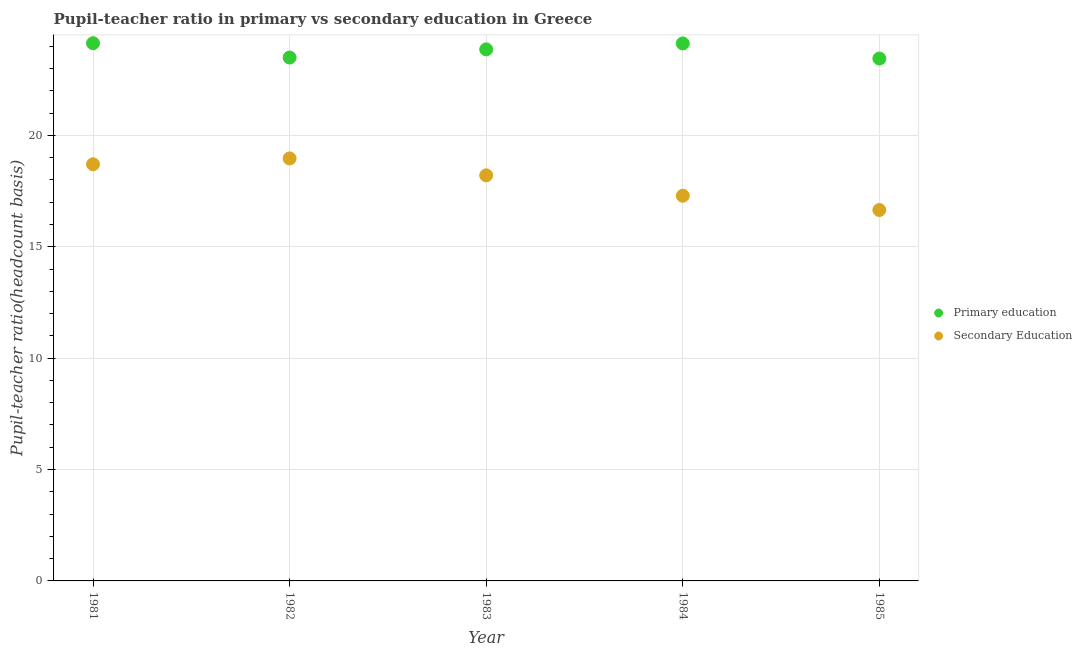Is the number of dotlines equal to the number of legend labels?
Keep it short and to the point. Yes. What is the pupil-teacher ratio in primary education in 1985?
Provide a succinct answer. 23.45. Across all years, what is the maximum pupil teacher ratio on secondary education?
Ensure brevity in your answer.  18.97. Across all years, what is the minimum pupil-teacher ratio in primary education?
Provide a short and direct response. 23.45. What is the total pupil teacher ratio on secondary education in the graph?
Ensure brevity in your answer.  89.81. What is the difference between the pupil-teacher ratio in primary education in 1981 and that in 1982?
Make the answer very short. 0.64. What is the difference between the pupil-teacher ratio in primary education in 1982 and the pupil teacher ratio on secondary education in 1981?
Your answer should be very brief. 4.79. What is the average pupil teacher ratio on secondary education per year?
Offer a very short reply. 17.96. In the year 1985, what is the difference between the pupil teacher ratio on secondary education and pupil-teacher ratio in primary education?
Your response must be concise. -6.8. In how many years, is the pupil-teacher ratio in primary education greater than 3?
Give a very brief answer. 5. What is the ratio of the pupil teacher ratio on secondary education in 1981 to that in 1984?
Offer a very short reply. 1.08. What is the difference between the highest and the second highest pupil teacher ratio on secondary education?
Make the answer very short. 0.26. What is the difference between the highest and the lowest pupil-teacher ratio in primary education?
Your answer should be compact. 0.69. In how many years, is the pupil-teacher ratio in primary education greater than the average pupil-teacher ratio in primary education taken over all years?
Give a very brief answer. 3. Does the pupil-teacher ratio in primary education monotonically increase over the years?
Keep it short and to the point. No. Is the pupil teacher ratio on secondary education strictly greater than the pupil-teacher ratio in primary education over the years?
Provide a succinct answer. No. How many dotlines are there?
Offer a terse response. 2. What is the difference between two consecutive major ticks on the Y-axis?
Ensure brevity in your answer.  5. Does the graph contain any zero values?
Your response must be concise. No. Does the graph contain grids?
Keep it short and to the point. Yes. Where does the legend appear in the graph?
Give a very brief answer. Center right. How many legend labels are there?
Provide a short and direct response. 2. How are the legend labels stacked?
Ensure brevity in your answer.  Vertical. What is the title of the graph?
Keep it short and to the point. Pupil-teacher ratio in primary vs secondary education in Greece. What is the label or title of the Y-axis?
Make the answer very short. Pupil-teacher ratio(headcount basis). What is the Pupil-teacher ratio(headcount basis) of Primary education in 1981?
Provide a short and direct response. 24.14. What is the Pupil-teacher ratio(headcount basis) of Secondary Education in 1981?
Offer a very short reply. 18.7. What is the Pupil-teacher ratio(headcount basis) of Primary education in 1982?
Offer a very short reply. 23.49. What is the Pupil-teacher ratio(headcount basis) of Secondary Education in 1982?
Your answer should be compact. 18.97. What is the Pupil-teacher ratio(headcount basis) of Primary education in 1983?
Your answer should be very brief. 23.86. What is the Pupil-teacher ratio(headcount basis) in Secondary Education in 1983?
Your answer should be very brief. 18.21. What is the Pupil-teacher ratio(headcount basis) in Primary education in 1984?
Your response must be concise. 24.13. What is the Pupil-teacher ratio(headcount basis) in Secondary Education in 1984?
Provide a short and direct response. 17.29. What is the Pupil-teacher ratio(headcount basis) in Primary education in 1985?
Offer a very short reply. 23.45. What is the Pupil-teacher ratio(headcount basis) in Secondary Education in 1985?
Keep it short and to the point. 16.65. Across all years, what is the maximum Pupil-teacher ratio(headcount basis) in Primary education?
Your answer should be very brief. 24.14. Across all years, what is the maximum Pupil-teacher ratio(headcount basis) in Secondary Education?
Offer a very short reply. 18.97. Across all years, what is the minimum Pupil-teacher ratio(headcount basis) of Primary education?
Make the answer very short. 23.45. Across all years, what is the minimum Pupil-teacher ratio(headcount basis) of Secondary Education?
Make the answer very short. 16.65. What is the total Pupil-teacher ratio(headcount basis) in Primary education in the graph?
Keep it short and to the point. 119.06. What is the total Pupil-teacher ratio(headcount basis) in Secondary Education in the graph?
Provide a succinct answer. 89.81. What is the difference between the Pupil-teacher ratio(headcount basis) in Primary education in 1981 and that in 1982?
Offer a very short reply. 0.64. What is the difference between the Pupil-teacher ratio(headcount basis) in Secondary Education in 1981 and that in 1982?
Give a very brief answer. -0.26. What is the difference between the Pupil-teacher ratio(headcount basis) in Primary education in 1981 and that in 1983?
Keep it short and to the point. 0.28. What is the difference between the Pupil-teacher ratio(headcount basis) in Secondary Education in 1981 and that in 1983?
Provide a succinct answer. 0.5. What is the difference between the Pupil-teacher ratio(headcount basis) in Primary education in 1981 and that in 1984?
Give a very brief answer. 0.01. What is the difference between the Pupil-teacher ratio(headcount basis) of Secondary Education in 1981 and that in 1984?
Your answer should be compact. 1.41. What is the difference between the Pupil-teacher ratio(headcount basis) in Primary education in 1981 and that in 1985?
Make the answer very short. 0.69. What is the difference between the Pupil-teacher ratio(headcount basis) of Secondary Education in 1981 and that in 1985?
Your answer should be compact. 2.05. What is the difference between the Pupil-teacher ratio(headcount basis) in Primary education in 1982 and that in 1983?
Keep it short and to the point. -0.37. What is the difference between the Pupil-teacher ratio(headcount basis) in Secondary Education in 1982 and that in 1983?
Offer a very short reply. 0.76. What is the difference between the Pupil-teacher ratio(headcount basis) in Primary education in 1982 and that in 1984?
Offer a very short reply. -0.63. What is the difference between the Pupil-teacher ratio(headcount basis) in Secondary Education in 1982 and that in 1984?
Ensure brevity in your answer.  1.68. What is the difference between the Pupil-teacher ratio(headcount basis) in Primary education in 1982 and that in 1985?
Your answer should be compact. 0.05. What is the difference between the Pupil-teacher ratio(headcount basis) in Secondary Education in 1982 and that in 1985?
Offer a very short reply. 2.32. What is the difference between the Pupil-teacher ratio(headcount basis) of Primary education in 1983 and that in 1984?
Provide a succinct answer. -0.27. What is the difference between the Pupil-teacher ratio(headcount basis) in Secondary Education in 1983 and that in 1984?
Ensure brevity in your answer.  0.92. What is the difference between the Pupil-teacher ratio(headcount basis) of Primary education in 1983 and that in 1985?
Keep it short and to the point. 0.41. What is the difference between the Pupil-teacher ratio(headcount basis) of Secondary Education in 1983 and that in 1985?
Keep it short and to the point. 1.56. What is the difference between the Pupil-teacher ratio(headcount basis) in Primary education in 1984 and that in 1985?
Offer a terse response. 0.68. What is the difference between the Pupil-teacher ratio(headcount basis) of Secondary Education in 1984 and that in 1985?
Your answer should be compact. 0.64. What is the difference between the Pupil-teacher ratio(headcount basis) of Primary education in 1981 and the Pupil-teacher ratio(headcount basis) of Secondary Education in 1982?
Provide a succinct answer. 5.17. What is the difference between the Pupil-teacher ratio(headcount basis) of Primary education in 1981 and the Pupil-teacher ratio(headcount basis) of Secondary Education in 1983?
Make the answer very short. 5.93. What is the difference between the Pupil-teacher ratio(headcount basis) in Primary education in 1981 and the Pupil-teacher ratio(headcount basis) in Secondary Education in 1984?
Your answer should be compact. 6.85. What is the difference between the Pupil-teacher ratio(headcount basis) of Primary education in 1981 and the Pupil-teacher ratio(headcount basis) of Secondary Education in 1985?
Offer a terse response. 7.49. What is the difference between the Pupil-teacher ratio(headcount basis) in Primary education in 1982 and the Pupil-teacher ratio(headcount basis) in Secondary Education in 1983?
Ensure brevity in your answer.  5.29. What is the difference between the Pupil-teacher ratio(headcount basis) in Primary education in 1982 and the Pupil-teacher ratio(headcount basis) in Secondary Education in 1984?
Provide a succinct answer. 6.2. What is the difference between the Pupil-teacher ratio(headcount basis) of Primary education in 1982 and the Pupil-teacher ratio(headcount basis) of Secondary Education in 1985?
Offer a very short reply. 6.84. What is the difference between the Pupil-teacher ratio(headcount basis) of Primary education in 1983 and the Pupil-teacher ratio(headcount basis) of Secondary Education in 1984?
Your answer should be compact. 6.57. What is the difference between the Pupil-teacher ratio(headcount basis) in Primary education in 1983 and the Pupil-teacher ratio(headcount basis) in Secondary Education in 1985?
Make the answer very short. 7.21. What is the difference between the Pupil-teacher ratio(headcount basis) of Primary education in 1984 and the Pupil-teacher ratio(headcount basis) of Secondary Education in 1985?
Your answer should be compact. 7.48. What is the average Pupil-teacher ratio(headcount basis) of Primary education per year?
Ensure brevity in your answer.  23.81. What is the average Pupil-teacher ratio(headcount basis) in Secondary Education per year?
Your answer should be compact. 17.96. In the year 1981, what is the difference between the Pupil-teacher ratio(headcount basis) in Primary education and Pupil-teacher ratio(headcount basis) in Secondary Education?
Offer a very short reply. 5.43. In the year 1982, what is the difference between the Pupil-teacher ratio(headcount basis) in Primary education and Pupil-teacher ratio(headcount basis) in Secondary Education?
Ensure brevity in your answer.  4.53. In the year 1983, what is the difference between the Pupil-teacher ratio(headcount basis) of Primary education and Pupil-teacher ratio(headcount basis) of Secondary Education?
Your answer should be compact. 5.65. In the year 1984, what is the difference between the Pupil-teacher ratio(headcount basis) of Primary education and Pupil-teacher ratio(headcount basis) of Secondary Education?
Provide a short and direct response. 6.84. In the year 1985, what is the difference between the Pupil-teacher ratio(headcount basis) of Primary education and Pupil-teacher ratio(headcount basis) of Secondary Education?
Keep it short and to the point. 6.8. What is the ratio of the Pupil-teacher ratio(headcount basis) in Primary education in 1981 to that in 1982?
Your response must be concise. 1.03. What is the ratio of the Pupil-teacher ratio(headcount basis) of Secondary Education in 1981 to that in 1982?
Your answer should be compact. 0.99. What is the ratio of the Pupil-teacher ratio(headcount basis) in Primary education in 1981 to that in 1983?
Your answer should be compact. 1.01. What is the ratio of the Pupil-teacher ratio(headcount basis) in Secondary Education in 1981 to that in 1983?
Your answer should be very brief. 1.03. What is the ratio of the Pupil-teacher ratio(headcount basis) in Secondary Education in 1981 to that in 1984?
Your answer should be compact. 1.08. What is the ratio of the Pupil-teacher ratio(headcount basis) of Primary education in 1981 to that in 1985?
Give a very brief answer. 1.03. What is the ratio of the Pupil-teacher ratio(headcount basis) of Secondary Education in 1981 to that in 1985?
Give a very brief answer. 1.12. What is the ratio of the Pupil-teacher ratio(headcount basis) in Primary education in 1982 to that in 1983?
Make the answer very short. 0.98. What is the ratio of the Pupil-teacher ratio(headcount basis) of Secondary Education in 1982 to that in 1983?
Make the answer very short. 1.04. What is the ratio of the Pupil-teacher ratio(headcount basis) of Primary education in 1982 to that in 1984?
Make the answer very short. 0.97. What is the ratio of the Pupil-teacher ratio(headcount basis) in Secondary Education in 1982 to that in 1984?
Make the answer very short. 1.1. What is the ratio of the Pupil-teacher ratio(headcount basis) of Secondary Education in 1982 to that in 1985?
Your answer should be very brief. 1.14. What is the ratio of the Pupil-teacher ratio(headcount basis) in Primary education in 1983 to that in 1984?
Offer a very short reply. 0.99. What is the ratio of the Pupil-teacher ratio(headcount basis) of Secondary Education in 1983 to that in 1984?
Make the answer very short. 1.05. What is the ratio of the Pupil-teacher ratio(headcount basis) in Primary education in 1983 to that in 1985?
Provide a succinct answer. 1.02. What is the ratio of the Pupil-teacher ratio(headcount basis) of Secondary Education in 1983 to that in 1985?
Provide a succinct answer. 1.09. What is the ratio of the Pupil-teacher ratio(headcount basis) of Primary education in 1984 to that in 1985?
Provide a succinct answer. 1.03. What is the ratio of the Pupil-teacher ratio(headcount basis) in Secondary Education in 1984 to that in 1985?
Provide a succinct answer. 1.04. What is the difference between the highest and the second highest Pupil-teacher ratio(headcount basis) in Primary education?
Your answer should be very brief. 0.01. What is the difference between the highest and the second highest Pupil-teacher ratio(headcount basis) in Secondary Education?
Your answer should be compact. 0.26. What is the difference between the highest and the lowest Pupil-teacher ratio(headcount basis) in Primary education?
Provide a succinct answer. 0.69. What is the difference between the highest and the lowest Pupil-teacher ratio(headcount basis) in Secondary Education?
Provide a succinct answer. 2.32. 